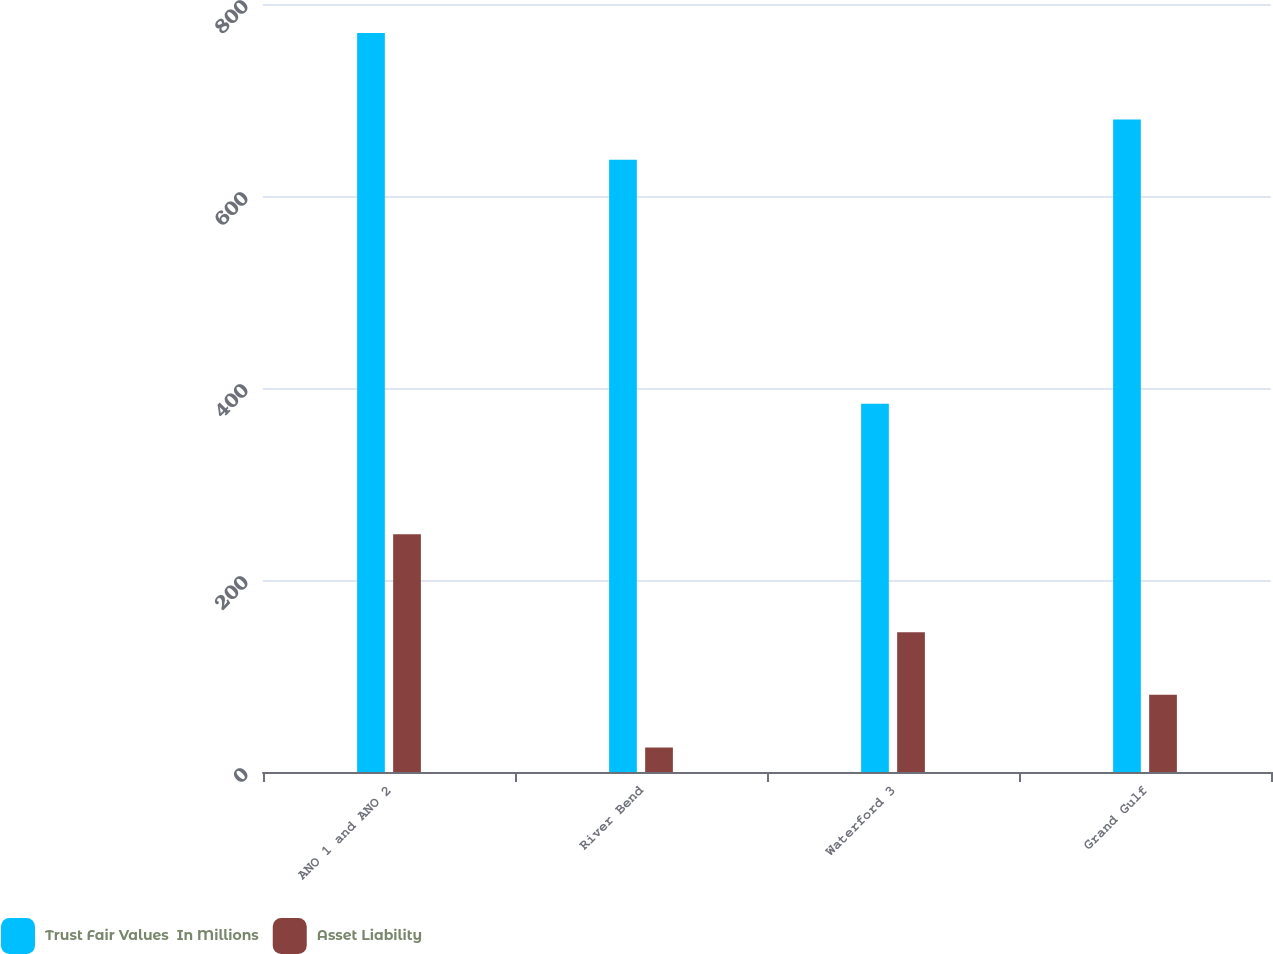<chart> <loc_0><loc_0><loc_500><loc_500><stacked_bar_chart><ecel><fcel>ANO 1 and ANO 2<fcel>River Bend<fcel>Waterford 3<fcel>Grand Gulf<nl><fcel>Trust Fair Values  In Millions<fcel>769.9<fcel>637.7<fcel>383.6<fcel>679.8<nl><fcel>Asset Liability<fcel>247.6<fcel>25.5<fcel>145.5<fcel>80.4<nl></chart> 